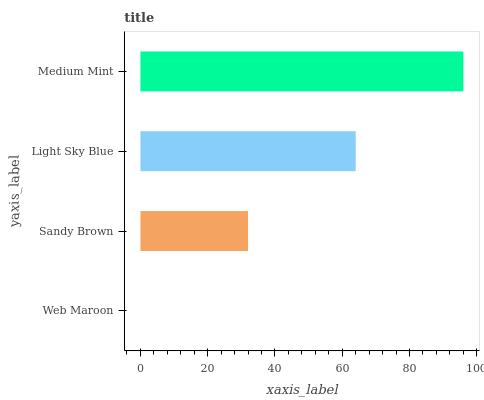Is Web Maroon the minimum?
Answer yes or no. Yes. Is Medium Mint the maximum?
Answer yes or no. Yes. Is Sandy Brown the minimum?
Answer yes or no. No. Is Sandy Brown the maximum?
Answer yes or no. No. Is Sandy Brown greater than Web Maroon?
Answer yes or no. Yes. Is Web Maroon less than Sandy Brown?
Answer yes or no. Yes. Is Web Maroon greater than Sandy Brown?
Answer yes or no. No. Is Sandy Brown less than Web Maroon?
Answer yes or no. No. Is Light Sky Blue the high median?
Answer yes or no. Yes. Is Sandy Brown the low median?
Answer yes or no. Yes. Is Web Maroon the high median?
Answer yes or no. No. Is Medium Mint the low median?
Answer yes or no. No. 